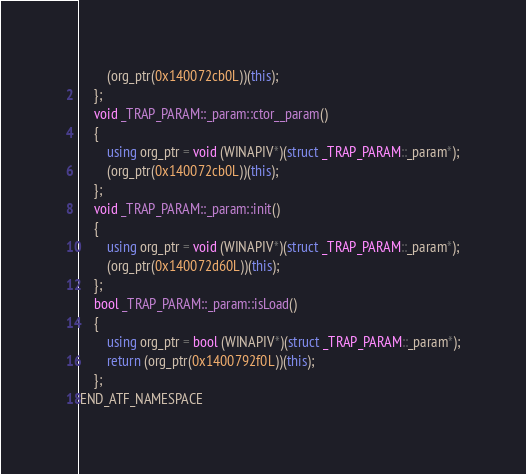Convert code to text. <code><loc_0><loc_0><loc_500><loc_500><_C++_>        (org_ptr(0x140072cb0L))(this);
    };
    void _TRAP_PARAM::_param::ctor__param()
    {
        using org_ptr = void (WINAPIV*)(struct _TRAP_PARAM::_param*);
        (org_ptr(0x140072cb0L))(this);
    };
    void _TRAP_PARAM::_param::init()
    {
        using org_ptr = void (WINAPIV*)(struct _TRAP_PARAM::_param*);
        (org_ptr(0x140072d60L))(this);
    };
    bool _TRAP_PARAM::_param::isLoad()
    {
        using org_ptr = bool (WINAPIV*)(struct _TRAP_PARAM::_param*);
        return (org_ptr(0x1400792f0L))(this);
    };
END_ATF_NAMESPACE
</code> 